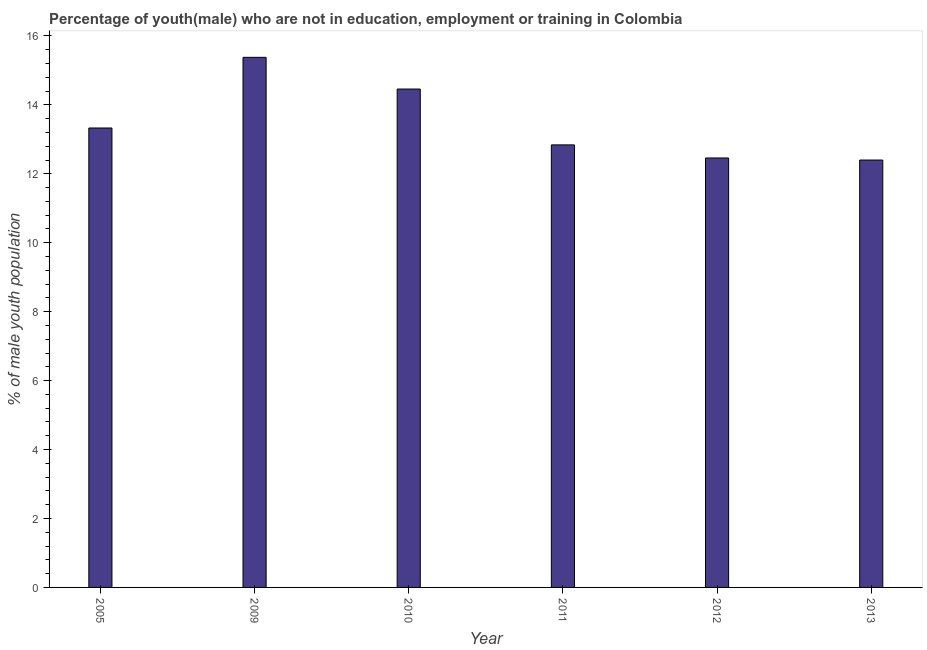Does the graph contain any zero values?
Your answer should be compact. No. What is the title of the graph?
Your answer should be compact. Percentage of youth(male) who are not in education, employment or training in Colombia. What is the label or title of the X-axis?
Provide a short and direct response. Year. What is the label or title of the Y-axis?
Ensure brevity in your answer.  % of male youth population. What is the unemployed male youth population in 2009?
Ensure brevity in your answer.  15.38. Across all years, what is the maximum unemployed male youth population?
Your response must be concise. 15.38. Across all years, what is the minimum unemployed male youth population?
Offer a very short reply. 12.4. In which year was the unemployed male youth population minimum?
Your answer should be compact. 2013. What is the sum of the unemployed male youth population?
Provide a succinct answer. 80.87. What is the difference between the unemployed male youth population in 2011 and 2012?
Offer a terse response. 0.38. What is the average unemployed male youth population per year?
Your answer should be compact. 13.48. What is the median unemployed male youth population?
Provide a succinct answer. 13.09. In how many years, is the unemployed male youth population greater than 10.8 %?
Your answer should be compact. 6. Do a majority of the years between 2011 and 2012 (inclusive) have unemployed male youth population greater than 1.6 %?
Ensure brevity in your answer.  Yes. Is the difference between the unemployed male youth population in 2005 and 2009 greater than the difference between any two years?
Your answer should be compact. No. What is the difference between the highest and the second highest unemployed male youth population?
Give a very brief answer. 0.92. What is the difference between the highest and the lowest unemployed male youth population?
Keep it short and to the point. 2.98. In how many years, is the unemployed male youth population greater than the average unemployed male youth population taken over all years?
Provide a short and direct response. 2. How many bars are there?
Your response must be concise. 6. Are all the bars in the graph horizontal?
Provide a short and direct response. No. What is the % of male youth population of 2005?
Keep it short and to the point. 13.33. What is the % of male youth population in 2009?
Your answer should be compact. 15.38. What is the % of male youth population in 2010?
Provide a short and direct response. 14.46. What is the % of male youth population of 2011?
Your answer should be compact. 12.84. What is the % of male youth population of 2012?
Keep it short and to the point. 12.46. What is the % of male youth population of 2013?
Your answer should be very brief. 12.4. What is the difference between the % of male youth population in 2005 and 2009?
Your response must be concise. -2.05. What is the difference between the % of male youth population in 2005 and 2010?
Your answer should be very brief. -1.13. What is the difference between the % of male youth population in 2005 and 2011?
Provide a succinct answer. 0.49. What is the difference between the % of male youth population in 2005 and 2012?
Your answer should be compact. 0.87. What is the difference between the % of male youth population in 2009 and 2011?
Ensure brevity in your answer.  2.54. What is the difference between the % of male youth population in 2009 and 2012?
Keep it short and to the point. 2.92. What is the difference between the % of male youth population in 2009 and 2013?
Offer a terse response. 2.98. What is the difference between the % of male youth population in 2010 and 2011?
Give a very brief answer. 1.62. What is the difference between the % of male youth population in 2010 and 2012?
Your response must be concise. 2. What is the difference between the % of male youth population in 2010 and 2013?
Provide a short and direct response. 2.06. What is the difference between the % of male youth population in 2011 and 2012?
Keep it short and to the point. 0.38. What is the difference between the % of male youth population in 2011 and 2013?
Provide a short and direct response. 0.44. What is the difference between the % of male youth population in 2012 and 2013?
Offer a terse response. 0.06. What is the ratio of the % of male youth population in 2005 to that in 2009?
Offer a terse response. 0.87. What is the ratio of the % of male youth population in 2005 to that in 2010?
Ensure brevity in your answer.  0.92. What is the ratio of the % of male youth population in 2005 to that in 2011?
Make the answer very short. 1.04. What is the ratio of the % of male youth population in 2005 to that in 2012?
Your response must be concise. 1.07. What is the ratio of the % of male youth population in 2005 to that in 2013?
Your answer should be compact. 1.07. What is the ratio of the % of male youth population in 2009 to that in 2010?
Your answer should be compact. 1.06. What is the ratio of the % of male youth population in 2009 to that in 2011?
Give a very brief answer. 1.2. What is the ratio of the % of male youth population in 2009 to that in 2012?
Your answer should be compact. 1.23. What is the ratio of the % of male youth population in 2009 to that in 2013?
Offer a terse response. 1.24. What is the ratio of the % of male youth population in 2010 to that in 2011?
Offer a very short reply. 1.13. What is the ratio of the % of male youth population in 2010 to that in 2012?
Your response must be concise. 1.16. What is the ratio of the % of male youth population in 2010 to that in 2013?
Make the answer very short. 1.17. What is the ratio of the % of male youth population in 2011 to that in 2012?
Provide a succinct answer. 1.03. What is the ratio of the % of male youth population in 2011 to that in 2013?
Give a very brief answer. 1.03. What is the ratio of the % of male youth population in 2012 to that in 2013?
Give a very brief answer. 1. 